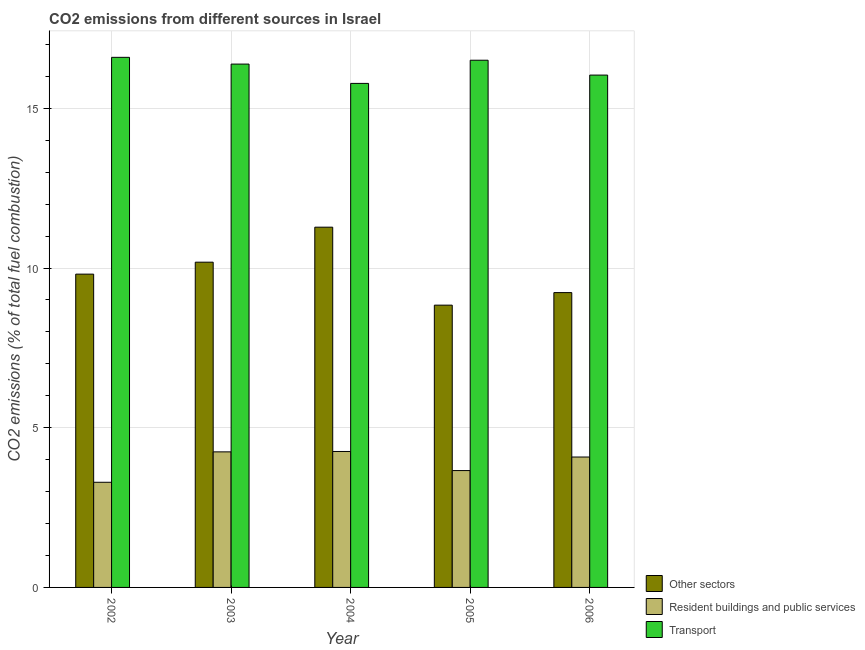How many groups of bars are there?
Provide a short and direct response. 5. How many bars are there on the 5th tick from the left?
Offer a terse response. 3. What is the label of the 3rd group of bars from the left?
Provide a short and direct response. 2004. What is the percentage of co2 emissions from resident buildings and public services in 2002?
Offer a very short reply. 3.29. Across all years, what is the maximum percentage of co2 emissions from resident buildings and public services?
Give a very brief answer. 4.26. Across all years, what is the minimum percentage of co2 emissions from resident buildings and public services?
Ensure brevity in your answer.  3.29. In which year was the percentage of co2 emissions from transport maximum?
Keep it short and to the point. 2002. What is the total percentage of co2 emissions from other sectors in the graph?
Keep it short and to the point. 49.34. What is the difference between the percentage of co2 emissions from other sectors in 2003 and that in 2005?
Make the answer very short. 1.35. What is the difference between the percentage of co2 emissions from transport in 2006 and the percentage of co2 emissions from resident buildings and public services in 2002?
Offer a very short reply. -0.56. What is the average percentage of co2 emissions from transport per year?
Provide a succinct answer. 16.26. In how many years, is the percentage of co2 emissions from transport greater than 5 %?
Ensure brevity in your answer.  5. What is the ratio of the percentage of co2 emissions from transport in 2004 to that in 2006?
Your answer should be very brief. 0.98. What is the difference between the highest and the second highest percentage of co2 emissions from transport?
Provide a succinct answer. 0.09. What is the difference between the highest and the lowest percentage of co2 emissions from transport?
Offer a very short reply. 0.82. In how many years, is the percentage of co2 emissions from other sectors greater than the average percentage of co2 emissions from other sectors taken over all years?
Offer a very short reply. 2. What does the 3rd bar from the left in 2002 represents?
Your answer should be compact. Transport. What does the 2nd bar from the right in 2005 represents?
Your response must be concise. Resident buildings and public services. How many bars are there?
Make the answer very short. 15. Are all the bars in the graph horizontal?
Provide a short and direct response. No. How many years are there in the graph?
Offer a very short reply. 5. Are the values on the major ticks of Y-axis written in scientific E-notation?
Keep it short and to the point. No. What is the title of the graph?
Your response must be concise. CO2 emissions from different sources in Israel. What is the label or title of the Y-axis?
Your answer should be compact. CO2 emissions (% of total fuel combustion). What is the CO2 emissions (% of total fuel combustion) of Other sectors in 2002?
Your answer should be compact. 9.81. What is the CO2 emissions (% of total fuel combustion) of Resident buildings and public services in 2002?
Keep it short and to the point. 3.29. What is the CO2 emissions (% of total fuel combustion) of Transport in 2002?
Provide a short and direct response. 16.6. What is the CO2 emissions (% of total fuel combustion) in Other sectors in 2003?
Provide a short and direct response. 10.18. What is the CO2 emissions (% of total fuel combustion) in Resident buildings and public services in 2003?
Make the answer very short. 4.24. What is the CO2 emissions (% of total fuel combustion) of Transport in 2003?
Offer a very short reply. 16.38. What is the CO2 emissions (% of total fuel combustion) of Other sectors in 2004?
Offer a very short reply. 11.28. What is the CO2 emissions (% of total fuel combustion) in Resident buildings and public services in 2004?
Offer a very short reply. 4.26. What is the CO2 emissions (% of total fuel combustion) in Transport in 2004?
Offer a very short reply. 15.78. What is the CO2 emissions (% of total fuel combustion) of Other sectors in 2005?
Provide a succinct answer. 8.84. What is the CO2 emissions (% of total fuel combustion) of Resident buildings and public services in 2005?
Provide a succinct answer. 3.66. What is the CO2 emissions (% of total fuel combustion) in Transport in 2005?
Provide a succinct answer. 16.51. What is the CO2 emissions (% of total fuel combustion) of Other sectors in 2006?
Your answer should be very brief. 9.23. What is the CO2 emissions (% of total fuel combustion) of Resident buildings and public services in 2006?
Offer a terse response. 4.08. What is the CO2 emissions (% of total fuel combustion) in Transport in 2006?
Your answer should be very brief. 16.04. Across all years, what is the maximum CO2 emissions (% of total fuel combustion) in Other sectors?
Provide a succinct answer. 11.28. Across all years, what is the maximum CO2 emissions (% of total fuel combustion) in Resident buildings and public services?
Provide a succinct answer. 4.26. Across all years, what is the maximum CO2 emissions (% of total fuel combustion) in Transport?
Give a very brief answer. 16.6. Across all years, what is the minimum CO2 emissions (% of total fuel combustion) of Other sectors?
Your answer should be very brief. 8.84. Across all years, what is the minimum CO2 emissions (% of total fuel combustion) of Resident buildings and public services?
Provide a succinct answer. 3.29. Across all years, what is the minimum CO2 emissions (% of total fuel combustion) of Transport?
Your response must be concise. 15.78. What is the total CO2 emissions (% of total fuel combustion) of Other sectors in the graph?
Your response must be concise. 49.34. What is the total CO2 emissions (% of total fuel combustion) of Resident buildings and public services in the graph?
Give a very brief answer. 19.53. What is the total CO2 emissions (% of total fuel combustion) of Transport in the graph?
Provide a succinct answer. 81.31. What is the difference between the CO2 emissions (% of total fuel combustion) of Other sectors in 2002 and that in 2003?
Your response must be concise. -0.37. What is the difference between the CO2 emissions (% of total fuel combustion) in Resident buildings and public services in 2002 and that in 2003?
Keep it short and to the point. -0.95. What is the difference between the CO2 emissions (% of total fuel combustion) of Transport in 2002 and that in 2003?
Your answer should be compact. 0.21. What is the difference between the CO2 emissions (% of total fuel combustion) of Other sectors in 2002 and that in 2004?
Make the answer very short. -1.47. What is the difference between the CO2 emissions (% of total fuel combustion) in Resident buildings and public services in 2002 and that in 2004?
Provide a succinct answer. -0.96. What is the difference between the CO2 emissions (% of total fuel combustion) of Transport in 2002 and that in 2004?
Your answer should be very brief. 0.82. What is the difference between the CO2 emissions (% of total fuel combustion) in Other sectors in 2002 and that in 2005?
Offer a very short reply. 0.97. What is the difference between the CO2 emissions (% of total fuel combustion) in Resident buildings and public services in 2002 and that in 2005?
Your response must be concise. -0.37. What is the difference between the CO2 emissions (% of total fuel combustion) of Transport in 2002 and that in 2005?
Offer a very short reply. 0.09. What is the difference between the CO2 emissions (% of total fuel combustion) in Other sectors in 2002 and that in 2006?
Offer a terse response. 0.58. What is the difference between the CO2 emissions (% of total fuel combustion) of Resident buildings and public services in 2002 and that in 2006?
Provide a short and direct response. -0.79. What is the difference between the CO2 emissions (% of total fuel combustion) in Transport in 2002 and that in 2006?
Offer a very short reply. 0.56. What is the difference between the CO2 emissions (% of total fuel combustion) in Other sectors in 2003 and that in 2004?
Provide a succinct answer. -1.1. What is the difference between the CO2 emissions (% of total fuel combustion) in Resident buildings and public services in 2003 and that in 2004?
Give a very brief answer. -0.01. What is the difference between the CO2 emissions (% of total fuel combustion) of Transport in 2003 and that in 2004?
Provide a short and direct response. 0.6. What is the difference between the CO2 emissions (% of total fuel combustion) in Other sectors in 2003 and that in 2005?
Keep it short and to the point. 1.35. What is the difference between the CO2 emissions (% of total fuel combustion) in Resident buildings and public services in 2003 and that in 2005?
Your answer should be compact. 0.59. What is the difference between the CO2 emissions (% of total fuel combustion) of Transport in 2003 and that in 2005?
Offer a very short reply. -0.12. What is the difference between the CO2 emissions (% of total fuel combustion) in Other sectors in 2003 and that in 2006?
Keep it short and to the point. 0.95. What is the difference between the CO2 emissions (% of total fuel combustion) of Resident buildings and public services in 2003 and that in 2006?
Ensure brevity in your answer.  0.16. What is the difference between the CO2 emissions (% of total fuel combustion) of Transport in 2003 and that in 2006?
Your response must be concise. 0.34. What is the difference between the CO2 emissions (% of total fuel combustion) of Other sectors in 2004 and that in 2005?
Ensure brevity in your answer.  2.44. What is the difference between the CO2 emissions (% of total fuel combustion) of Resident buildings and public services in 2004 and that in 2005?
Your response must be concise. 0.6. What is the difference between the CO2 emissions (% of total fuel combustion) in Transport in 2004 and that in 2005?
Provide a short and direct response. -0.73. What is the difference between the CO2 emissions (% of total fuel combustion) of Other sectors in 2004 and that in 2006?
Keep it short and to the point. 2.05. What is the difference between the CO2 emissions (% of total fuel combustion) in Resident buildings and public services in 2004 and that in 2006?
Your answer should be compact. 0.17. What is the difference between the CO2 emissions (% of total fuel combustion) of Transport in 2004 and that in 2006?
Make the answer very short. -0.26. What is the difference between the CO2 emissions (% of total fuel combustion) of Other sectors in 2005 and that in 2006?
Ensure brevity in your answer.  -0.39. What is the difference between the CO2 emissions (% of total fuel combustion) in Resident buildings and public services in 2005 and that in 2006?
Offer a terse response. -0.42. What is the difference between the CO2 emissions (% of total fuel combustion) in Transport in 2005 and that in 2006?
Offer a very short reply. 0.47. What is the difference between the CO2 emissions (% of total fuel combustion) of Other sectors in 2002 and the CO2 emissions (% of total fuel combustion) of Resident buildings and public services in 2003?
Your answer should be very brief. 5.56. What is the difference between the CO2 emissions (% of total fuel combustion) of Other sectors in 2002 and the CO2 emissions (% of total fuel combustion) of Transport in 2003?
Your answer should be compact. -6.58. What is the difference between the CO2 emissions (% of total fuel combustion) in Resident buildings and public services in 2002 and the CO2 emissions (% of total fuel combustion) in Transport in 2003?
Make the answer very short. -13.09. What is the difference between the CO2 emissions (% of total fuel combustion) in Other sectors in 2002 and the CO2 emissions (% of total fuel combustion) in Resident buildings and public services in 2004?
Ensure brevity in your answer.  5.55. What is the difference between the CO2 emissions (% of total fuel combustion) of Other sectors in 2002 and the CO2 emissions (% of total fuel combustion) of Transport in 2004?
Provide a short and direct response. -5.97. What is the difference between the CO2 emissions (% of total fuel combustion) in Resident buildings and public services in 2002 and the CO2 emissions (% of total fuel combustion) in Transport in 2004?
Offer a very short reply. -12.49. What is the difference between the CO2 emissions (% of total fuel combustion) of Other sectors in 2002 and the CO2 emissions (% of total fuel combustion) of Resident buildings and public services in 2005?
Give a very brief answer. 6.15. What is the difference between the CO2 emissions (% of total fuel combustion) in Other sectors in 2002 and the CO2 emissions (% of total fuel combustion) in Transport in 2005?
Provide a short and direct response. -6.7. What is the difference between the CO2 emissions (% of total fuel combustion) in Resident buildings and public services in 2002 and the CO2 emissions (% of total fuel combustion) in Transport in 2005?
Provide a succinct answer. -13.21. What is the difference between the CO2 emissions (% of total fuel combustion) in Other sectors in 2002 and the CO2 emissions (% of total fuel combustion) in Resident buildings and public services in 2006?
Offer a terse response. 5.73. What is the difference between the CO2 emissions (% of total fuel combustion) of Other sectors in 2002 and the CO2 emissions (% of total fuel combustion) of Transport in 2006?
Give a very brief answer. -6.23. What is the difference between the CO2 emissions (% of total fuel combustion) in Resident buildings and public services in 2002 and the CO2 emissions (% of total fuel combustion) in Transport in 2006?
Give a very brief answer. -12.75. What is the difference between the CO2 emissions (% of total fuel combustion) of Other sectors in 2003 and the CO2 emissions (% of total fuel combustion) of Resident buildings and public services in 2004?
Make the answer very short. 5.93. What is the difference between the CO2 emissions (% of total fuel combustion) of Other sectors in 2003 and the CO2 emissions (% of total fuel combustion) of Transport in 2004?
Your response must be concise. -5.6. What is the difference between the CO2 emissions (% of total fuel combustion) in Resident buildings and public services in 2003 and the CO2 emissions (% of total fuel combustion) in Transport in 2004?
Offer a very short reply. -11.54. What is the difference between the CO2 emissions (% of total fuel combustion) of Other sectors in 2003 and the CO2 emissions (% of total fuel combustion) of Resident buildings and public services in 2005?
Your response must be concise. 6.52. What is the difference between the CO2 emissions (% of total fuel combustion) of Other sectors in 2003 and the CO2 emissions (% of total fuel combustion) of Transport in 2005?
Keep it short and to the point. -6.32. What is the difference between the CO2 emissions (% of total fuel combustion) of Resident buildings and public services in 2003 and the CO2 emissions (% of total fuel combustion) of Transport in 2005?
Provide a succinct answer. -12.26. What is the difference between the CO2 emissions (% of total fuel combustion) in Other sectors in 2003 and the CO2 emissions (% of total fuel combustion) in Resident buildings and public services in 2006?
Your answer should be very brief. 6.1. What is the difference between the CO2 emissions (% of total fuel combustion) of Other sectors in 2003 and the CO2 emissions (% of total fuel combustion) of Transport in 2006?
Make the answer very short. -5.86. What is the difference between the CO2 emissions (% of total fuel combustion) of Resident buildings and public services in 2003 and the CO2 emissions (% of total fuel combustion) of Transport in 2006?
Your answer should be very brief. -11.8. What is the difference between the CO2 emissions (% of total fuel combustion) in Other sectors in 2004 and the CO2 emissions (% of total fuel combustion) in Resident buildings and public services in 2005?
Offer a terse response. 7.62. What is the difference between the CO2 emissions (% of total fuel combustion) in Other sectors in 2004 and the CO2 emissions (% of total fuel combustion) in Transport in 2005?
Make the answer very short. -5.23. What is the difference between the CO2 emissions (% of total fuel combustion) of Resident buildings and public services in 2004 and the CO2 emissions (% of total fuel combustion) of Transport in 2005?
Provide a short and direct response. -12.25. What is the difference between the CO2 emissions (% of total fuel combustion) of Other sectors in 2004 and the CO2 emissions (% of total fuel combustion) of Resident buildings and public services in 2006?
Provide a short and direct response. 7.2. What is the difference between the CO2 emissions (% of total fuel combustion) of Other sectors in 2004 and the CO2 emissions (% of total fuel combustion) of Transport in 2006?
Provide a short and direct response. -4.76. What is the difference between the CO2 emissions (% of total fuel combustion) of Resident buildings and public services in 2004 and the CO2 emissions (% of total fuel combustion) of Transport in 2006?
Make the answer very short. -11.78. What is the difference between the CO2 emissions (% of total fuel combustion) in Other sectors in 2005 and the CO2 emissions (% of total fuel combustion) in Resident buildings and public services in 2006?
Ensure brevity in your answer.  4.75. What is the difference between the CO2 emissions (% of total fuel combustion) of Other sectors in 2005 and the CO2 emissions (% of total fuel combustion) of Transport in 2006?
Provide a succinct answer. -7.2. What is the difference between the CO2 emissions (% of total fuel combustion) in Resident buildings and public services in 2005 and the CO2 emissions (% of total fuel combustion) in Transport in 2006?
Your answer should be very brief. -12.38. What is the average CO2 emissions (% of total fuel combustion) in Other sectors per year?
Provide a succinct answer. 9.87. What is the average CO2 emissions (% of total fuel combustion) of Resident buildings and public services per year?
Ensure brevity in your answer.  3.91. What is the average CO2 emissions (% of total fuel combustion) of Transport per year?
Make the answer very short. 16.26. In the year 2002, what is the difference between the CO2 emissions (% of total fuel combustion) in Other sectors and CO2 emissions (% of total fuel combustion) in Resident buildings and public services?
Your answer should be very brief. 6.52. In the year 2002, what is the difference between the CO2 emissions (% of total fuel combustion) of Other sectors and CO2 emissions (% of total fuel combustion) of Transport?
Make the answer very short. -6.79. In the year 2002, what is the difference between the CO2 emissions (% of total fuel combustion) of Resident buildings and public services and CO2 emissions (% of total fuel combustion) of Transport?
Offer a terse response. -13.3. In the year 2003, what is the difference between the CO2 emissions (% of total fuel combustion) of Other sectors and CO2 emissions (% of total fuel combustion) of Resident buildings and public services?
Your response must be concise. 5.94. In the year 2003, what is the difference between the CO2 emissions (% of total fuel combustion) in Other sectors and CO2 emissions (% of total fuel combustion) in Transport?
Ensure brevity in your answer.  -6.2. In the year 2003, what is the difference between the CO2 emissions (% of total fuel combustion) of Resident buildings and public services and CO2 emissions (% of total fuel combustion) of Transport?
Offer a very short reply. -12.14. In the year 2004, what is the difference between the CO2 emissions (% of total fuel combustion) of Other sectors and CO2 emissions (% of total fuel combustion) of Resident buildings and public services?
Ensure brevity in your answer.  7.02. In the year 2004, what is the difference between the CO2 emissions (% of total fuel combustion) in Other sectors and CO2 emissions (% of total fuel combustion) in Transport?
Give a very brief answer. -4.5. In the year 2004, what is the difference between the CO2 emissions (% of total fuel combustion) of Resident buildings and public services and CO2 emissions (% of total fuel combustion) of Transport?
Give a very brief answer. -11.52. In the year 2005, what is the difference between the CO2 emissions (% of total fuel combustion) of Other sectors and CO2 emissions (% of total fuel combustion) of Resident buildings and public services?
Your response must be concise. 5.18. In the year 2005, what is the difference between the CO2 emissions (% of total fuel combustion) of Other sectors and CO2 emissions (% of total fuel combustion) of Transport?
Offer a terse response. -7.67. In the year 2005, what is the difference between the CO2 emissions (% of total fuel combustion) of Resident buildings and public services and CO2 emissions (% of total fuel combustion) of Transport?
Offer a very short reply. -12.85. In the year 2006, what is the difference between the CO2 emissions (% of total fuel combustion) in Other sectors and CO2 emissions (% of total fuel combustion) in Resident buildings and public services?
Give a very brief answer. 5.15. In the year 2006, what is the difference between the CO2 emissions (% of total fuel combustion) in Other sectors and CO2 emissions (% of total fuel combustion) in Transport?
Your answer should be very brief. -6.81. In the year 2006, what is the difference between the CO2 emissions (% of total fuel combustion) in Resident buildings and public services and CO2 emissions (% of total fuel combustion) in Transport?
Make the answer very short. -11.96. What is the ratio of the CO2 emissions (% of total fuel combustion) of Other sectors in 2002 to that in 2003?
Give a very brief answer. 0.96. What is the ratio of the CO2 emissions (% of total fuel combustion) in Resident buildings and public services in 2002 to that in 2003?
Your answer should be compact. 0.78. What is the ratio of the CO2 emissions (% of total fuel combustion) in Transport in 2002 to that in 2003?
Give a very brief answer. 1.01. What is the ratio of the CO2 emissions (% of total fuel combustion) of Other sectors in 2002 to that in 2004?
Keep it short and to the point. 0.87. What is the ratio of the CO2 emissions (% of total fuel combustion) of Resident buildings and public services in 2002 to that in 2004?
Your response must be concise. 0.77. What is the ratio of the CO2 emissions (% of total fuel combustion) of Transport in 2002 to that in 2004?
Keep it short and to the point. 1.05. What is the ratio of the CO2 emissions (% of total fuel combustion) in Other sectors in 2002 to that in 2005?
Give a very brief answer. 1.11. What is the ratio of the CO2 emissions (% of total fuel combustion) in Resident buildings and public services in 2002 to that in 2005?
Offer a very short reply. 0.9. What is the ratio of the CO2 emissions (% of total fuel combustion) in Transport in 2002 to that in 2005?
Offer a terse response. 1.01. What is the ratio of the CO2 emissions (% of total fuel combustion) in Other sectors in 2002 to that in 2006?
Your answer should be compact. 1.06. What is the ratio of the CO2 emissions (% of total fuel combustion) of Resident buildings and public services in 2002 to that in 2006?
Your answer should be very brief. 0.81. What is the ratio of the CO2 emissions (% of total fuel combustion) in Transport in 2002 to that in 2006?
Provide a succinct answer. 1.03. What is the ratio of the CO2 emissions (% of total fuel combustion) in Other sectors in 2003 to that in 2004?
Offer a very short reply. 0.9. What is the ratio of the CO2 emissions (% of total fuel combustion) of Resident buildings and public services in 2003 to that in 2004?
Your answer should be compact. 1. What is the ratio of the CO2 emissions (% of total fuel combustion) in Transport in 2003 to that in 2004?
Offer a terse response. 1.04. What is the ratio of the CO2 emissions (% of total fuel combustion) of Other sectors in 2003 to that in 2005?
Offer a terse response. 1.15. What is the ratio of the CO2 emissions (% of total fuel combustion) in Resident buildings and public services in 2003 to that in 2005?
Offer a very short reply. 1.16. What is the ratio of the CO2 emissions (% of total fuel combustion) of Transport in 2003 to that in 2005?
Keep it short and to the point. 0.99. What is the ratio of the CO2 emissions (% of total fuel combustion) of Other sectors in 2003 to that in 2006?
Give a very brief answer. 1.1. What is the ratio of the CO2 emissions (% of total fuel combustion) of Resident buildings and public services in 2003 to that in 2006?
Offer a terse response. 1.04. What is the ratio of the CO2 emissions (% of total fuel combustion) in Transport in 2003 to that in 2006?
Your answer should be compact. 1.02. What is the ratio of the CO2 emissions (% of total fuel combustion) of Other sectors in 2004 to that in 2005?
Offer a terse response. 1.28. What is the ratio of the CO2 emissions (% of total fuel combustion) of Resident buildings and public services in 2004 to that in 2005?
Provide a succinct answer. 1.16. What is the ratio of the CO2 emissions (% of total fuel combustion) in Transport in 2004 to that in 2005?
Provide a short and direct response. 0.96. What is the ratio of the CO2 emissions (% of total fuel combustion) of Other sectors in 2004 to that in 2006?
Your answer should be very brief. 1.22. What is the ratio of the CO2 emissions (% of total fuel combustion) of Resident buildings and public services in 2004 to that in 2006?
Give a very brief answer. 1.04. What is the ratio of the CO2 emissions (% of total fuel combustion) in Transport in 2004 to that in 2006?
Offer a very short reply. 0.98. What is the ratio of the CO2 emissions (% of total fuel combustion) in Other sectors in 2005 to that in 2006?
Make the answer very short. 0.96. What is the ratio of the CO2 emissions (% of total fuel combustion) in Resident buildings and public services in 2005 to that in 2006?
Your response must be concise. 0.9. What is the difference between the highest and the second highest CO2 emissions (% of total fuel combustion) in Other sectors?
Your answer should be very brief. 1.1. What is the difference between the highest and the second highest CO2 emissions (% of total fuel combustion) in Resident buildings and public services?
Keep it short and to the point. 0.01. What is the difference between the highest and the second highest CO2 emissions (% of total fuel combustion) in Transport?
Offer a terse response. 0.09. What is the difference between the highest and the lowest CO2 emissions (% of total fuel combustion) of Other sectors?
Your response must be concise. 2.44. What is the difference between the highest and the lowest CO2 emissions (% of total fuel combustion) in Transport?
Provide a short and direct response. 0.82. 